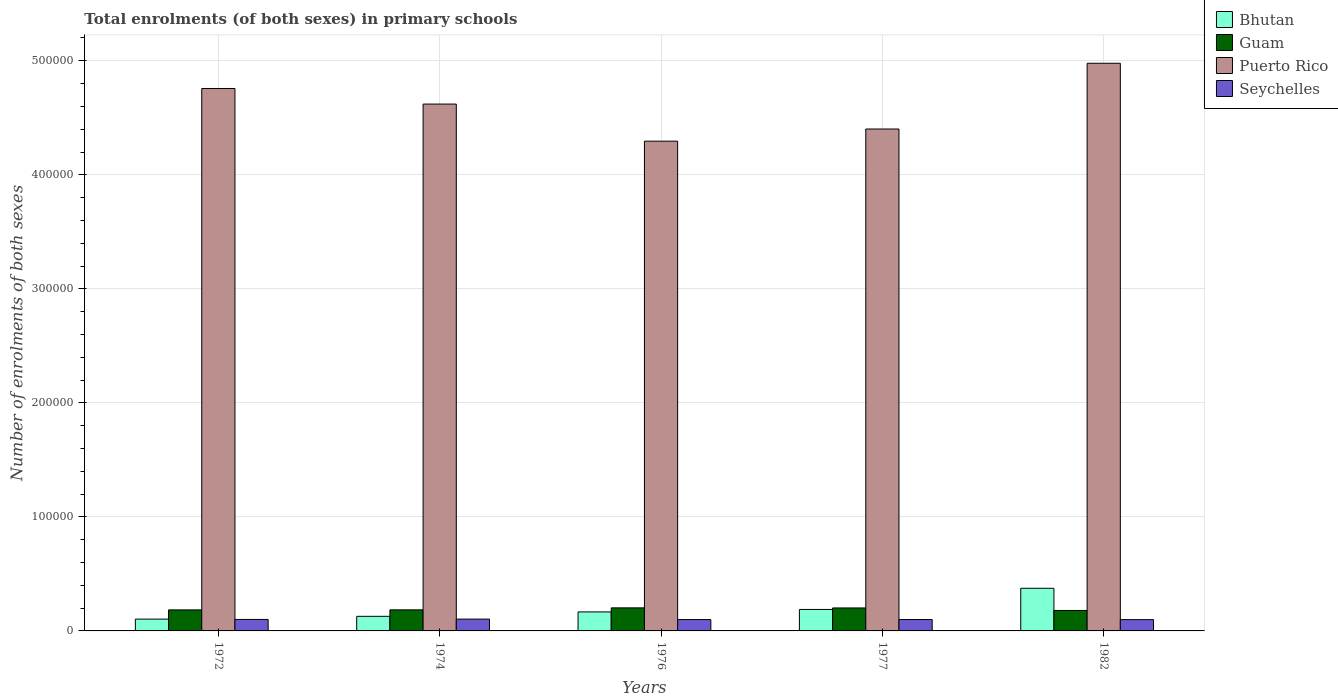How many groups of bars are there?
Keep it short and to the point. 5. Are the number of bars on each tick of the X-axis equal?
Your answer should be very brief. Yes. How many bars are there on the 1st tick from the right?
Your answer should be very brief. 4. What is the label of the 1st group of bars from the left?
Offer a very short reply. 1972. What is the number of enrolments in primary schools in Puerto Rico in 1974?
Your answer should be compact. 4.62e+05. Across all years, what is the maximum number of enrolments in primary schools in Puerto Rico?
Provide a succinct answer. 4.98e+05. Across all years, what is the minimum number of enrolments in primary schools in Seychelles?
Provide a succinct answer. 9897. In which year was the number of enrolments in primary schools in Bhutan maximum?
Provide a succinct answer. 1982. In which year was the number of enrolments in primary schools in Bhutan minimum?
Offer a terse response. 1972. What is the total number of enrolments in primary schools in Bhutan in the graph?
Provide a short and direct response. 9.61e+04. What is the difference between the number of enrolments in primary schools in Seychelles in 1974 and that in 1976?
Ensure brevity in your answer.  405. What is the difference between the number of enrolments in primary schools in Seychelles in 1982 and the number of enrolments in primary schools in Bhutan in 1976?
Your answer should be very brief. -6774. What is the average number of enrolments in primary schools in Puerto Rico per year?
Provide a succinct answer. 4.61e+05. In the year 1976, what is the difference between the number of enrolments in primary schools in Bhutan and number of enrolments in primary schools in Seychelles?
Provide a succinct answer. 6721. In how many years, is the number of enrolments in primary schools in Guam greater than 160000?
Ensure brevity in your answer.  0. What is the ratio of the number of enrolments in primary schools in Puerto Rico in 1974 to that in 1977?
Provide a short and direct response. 1.05. Is the number of enrolments in primary schools in Seychelles in 1977 less than that in 1982?
Your response must be concise. No. Is the difference between the number of enrolments in primary schools in Bhutan in 1974 and 1976 greater than the difference between the number of enrolments in primary schools in Seychelles in 1974 and 1976?
Give a very brief answer. No. What is the difference between the highest and the lowest number of enrolments in primary schools in Seychelles?
Provide a short and direct response. 458. In how many years, is the number of enrolments in primary schools in Seychelles greater than the average number of enrolments in primary schools in Seychelles taken over all years?
Offer a terse response. 2. Is it the case that in every year, the sum of the number of enrolments in primary schools in Seychelles and number of enrolments in primary schools in Puerto Rico is greater than the sum of number of enrolments in primary schools in Guam and number of enrolments in primary schools in Bhutan?
Provide a short and direct response. Yes. What does the 3rd bar from the left in 1977 represents?
Make the answer very short. Puerto Rico. What does the 4th bar from the right in 1976 represents?
Your answer should be compact. Bhutan. Is it the case that in every year, the sum of the number of enrolments in primary schools in Guam and number of enrolments in primary schools in Seychelles is greater than the number of enrolments in primary schools in Puerto Rico?
Provide a succinct answer. No. How many bars are there?
Your answer should be very brief. 20. What is the difference between two consecutive major ticks on the Y-axis?
Offer a very short reply. 1.00e+05. Are the values on the major ticks of Y-axis written in scientific E-notation?
Your answer should be very brief. No. Does the graph contain grids?
Your answer should be very brief. Yes. How many legend labels are there?
Your answer should be compact. 4. What is the title of the graph?
Ensure brevity in your answer.  Total enrolments (of both sexes) in primary schools. Does "Brazil" appear as one of the legend labels in the graph?
Offer a very short reply. No. What is the label or title of the Y-axis?
Keep it short and to the point. Number of enrolments of both sexes. What is the Number of enrolments of both sexes in Bhutan in 1972?
Offer a terse response. 1.04e+04. What is the Number of enrolments of both sexes in Guam in 1972?
Provide a succinct answer. 1.84e+04. What is the Number of enrolments of both sexes in Puerto Rico in 1972?
Make the answer very short. 4.76e+05. What is the Number of enrolments of both sexes of Seychelles in 1972?
Give a very brief answer. 1.01e+04. What is the Number of enrolments of both sexes in Bhutan in 1974?
Provide a short and direct response. 1.28e+04. What is the Number of enrolments of both sexes of Guam in 1974?
Offer a terse response. 1.85e+04. What is the Number of enrolments of both sexes of Puerto Rico in 1974?
Provide a succinct answer. 4.62e+05. What is the Number of enrolments of both sexes in Seychelles in 1974?
Keep it short and to the point. 1.04e+04. What is the Number of enrolments of both sexes of Bhutan in 1976?
Ensure brevity in your answer.  1.67e+04. What is the Number of enrolments of both sexes of Guam in 1976?
Give a very brief answer. 2.02e+04. What is the Number of enrolments of both sexes in Puerto Rico in 1976?
Give a very brief answer. 4.30e+05. What is the Number of enrolments of both sexes of Seychelles in 1976?
Ensure brevity in your answer.  9950. What is the Number of enrolments of both sexes of Bhutan in 1977?
Offer a very short reply. 1.88e+04. What is the Number of enrolments of both sexes in Guam in 1977?
Your answer should be very brief. 2.01e+04. What is the Number of enrolments of both sexes in Puerto Rico in 1977?
Offer a very short reply. 4.40e+05. What is the Number of enrolments of both sexes in Seychelles in 1977?
Make the answer very short. 1.00e+04. What is the Number of enrolments of both sexes of Bhutan in 1982?
Offer a terse response. 3.74e+04. What is the Number of enrolments of both sexes of Guam in 1982?
Provide a succinct answer. 1.79e+04. What is the Number of enrolments of both sexes of Puerto Rico in 1982?
Keep it short and to the point. 4.98e+05. What is the Number of enrolments of both sexes in Seychelles in 1982?
Ensure brevity in your answer.  9897. Across all years, what is the maximum Number of enrolments of both sexes of Bhutan?
Offer a very short reply. 3.74e+04. Across all years, what is the maximum Number of enrolments of both sexes in Guam?
Provide a short and direct response. 2.02e+04. Across all years, what is the maximum Number of enrolments of both sexes of Puerto Rico?
Ensure brevity in your answer.  4.98e+05. Across all years, what is the maximum Number of enrolments of both sexes in Seychelles?
Your answer should be very brief. 1.04e+04. Across all years, what is the minimum Number of enrolments of both sexes of Bhutan?
Ensure brevity in your answer.  1.04e+04. Across all years, what is the minimum Number of enrolments of both sexes of Guam?
Give a very brief answer. 1.79e+04. Across all years, what is the minimum Number of enrolments of both sexes in Puerto Rico?
Provide a short and direct response. 4.30e+05. Across all years, what is the minimum Number of enrolments of both sexes of Seychelles?
Offer a terse response. 9897. What is the total Number of enrolments of both sexes of Bhutan in the graph?
Give a very brief answer. 9.61e+04. What is the total Number of enrolments of both sexes of Guam in the graph?
Offer a very short reply. 9.52e+04. What is the total Number of enrolments of both sexes of Puerto Rico in the graph?
Offer a terse response. 2.31e+06. What is the total Number of enrolments of both sexes in Seychelles in the graph?
Your response must be concise. 5.03e+04. What is the difference between the Number of enrolments of both sexes in Bhutan in 1972 and that in 1974?
Offer a very short reply. -2449. What is the difference between the Number of enrolments of both sexes of Guam in 1972 and that in 1974?
Provide a succinct answer. -40. What is the difference between the Number of enrolments of both sexes in Puerto Rico in 1972 and that in 1974?
Make the answer very short. 1.37e+04. What is the difference between the Number of enrolments of both sexes of Seychelles in 1972 and that in 1974?
Provide a succinct answer. -281. What is the difference between the Number of enrolments of both sexes of Bhutan in 1972 and that in 1976?
Offer a very short reply. -6310. What is the difference between the Number of enrolments of both sexes in Guam in 1972 and that in 1976?
Make the answer very short. -1778. What is the difference between the Number of enrolments of both sexes in Puerto Rico in 1972 and that in 1976?
Your answer should be compact. 4.62e+04. What is the difference between the Number of enrolments of both sexes of Seychelles in 1972 and that in 1976?
Provide a short and direct response. 124. What is the difference between the Number of enrolments of both sexes of Bhutan in 1972 and that in 1977?
Make the answer very short. -8460. What is the difference between the Number of enrolments of both sexes of Guam in 1972 and that in 1977?
Provide a short and direct response. -1708. What is the difference between the Number of enrolments of both sexes in Puerto Rico in 1972 and that in 1977?
Your answer should be very brief. 3.55e+04. What is the difference between the Number of enrolments of both sexes in Bhutan in 1972 and that in 1982?
Provide a succinct answer. -2.70e+04. What is the difference between the Number of enrolments of both sexes in Guam in 1972 and that in 1982?
Make the answer very short. 492. What is the difference between the Number of enrolments of both sexes of Puerto Rico in 1972 and that in 1982?
Offer a very short reply. -2.21e+04. What is the difference between the Number of enrolments of both sexes of Seychelles in 1972 and that in 1982?
Your response must be concise. 177. What is the difference between the Number of enrolments of both sexes in Bhutan in 1974 and that in 1976?
Give a very brief answer. -3861. What is the difference between the Number of enrolments of both sexes in Guam in 1974 and that in 1976?
Your answer should be compact. -1738. What is the difference between the Number of enrolments of both sexes in Puerto Rico in 1974 and that in 1976?
Offer a terse response. 3.25e+04. What is the difference between the Number of enrolments of both sexes of Seychelles in 1974 and that in 1976?
Provide a succinct answer. 405. What is the difference between the Number of enrolments of both sexes in Bhutan in 1974 and that in 1977?
Provide a short and direct response. -6011. What is the difference between the Number of enrolments of both sexes of Guam in 1974 and that in 1977?
Keep it short and to the point. -1668. What is the difference between the Number of enrolments of both sexes of Puerto Rico in 1974 and that in 1977?
Offer a terse response. 2.19e+04. What is the difference between the Number of enrolments of both sexes of Seychelles in 1974 and that in 1977?
Make the answer very short. 354. What is the difference between the Number of enrolments of both sexes of Bhutan in 1974 and that in 1982?
Your response must be concise. -2.46e+04. What is the difference between the Number of enrolments of both sexes in Guam in 1974 and that in 1982?
Provide a short and direct response. 532. What is the difference between the Number of enrolments of both sexes of Puerto Rico in 1974 and that in 1982?
Provide a short and direct response. -3.58e+04. What is the difference between the Number of enrolments of both sexes of Seychelles in 1974 and that in 1982?
Your answer should be compact. 458. What is the difference between the Number of enrolments of both sexes of Bhutan in 1976 and that in 1977?
Provide a short and direct response. -2150. What is the difference between the Number of enrolments of both sexes in Guam in 1976 and that in 1977?
Your answer should be compact. 70. What is the difference between the Number of enrolments of both sexes of Puerto Rico in 1976 and that in 1977?
Make the answer very short. -1.07e+04. What is the difference between the Number of enrolments of both sexes in Seychelles in 1976 and that in 1977?
Provide a succinct answer. -51. What is the difference between the Number of enrolments of both sexes in Bhutan in 1976 and that in 1982?
Offer a very short reply. -2.07e+04. What is the difference between the Number of enrolments of both sexes of Guam in 1976 and that in 1982?
Your answer should be very brief. 2270. What is the difference between the Number of enrolments of both sexes of Puerto Rico in 1976 and that in 1982?
Keep it short and to the point. -6.83e+04. What is the difference between the Number of enrolments of both sexes of Seychelles in 1976 and that in 1982?
Ensure brevity in your answer.  53. What is the difference between the Number of enrolments of both sexes in Bhutan in 1977 and that in 1982?
Offer a terse response. -1.86e+04. What is the difference between the Number of enrolments of both sexes of Guam in 1977 and that in 1982?
Provide a succinct answer. 2200. What is the difference between the Number of enrolments of both sexes of Puerto Rico in 1977 and that in 1982?
Your response must be concise. -5.77e+04. What is the difference between the Number of enrolments of both sexes in Seychelles in 1977 and that in 1982?
Your answer should be compact. 104. What is the difference between the Number of enrolments of both sexes in Bhutan in 1972 and the Number of enrolments of both sexes in Guam in 1974?
Ensure brevity in your answer.  -8116. What is the difference between the Number of enrolments of both sexes in Bhutan in 1972 and the Number of enrolments of both sexes in Puerto Rico in 1974?
Keep it short and to the point. -4.52e+05. What is the difference between the Number of enrolments of both sexes in Bhutan in 1972 and the Number of enrolments of both sexes in Seychelles in 1974?
Provide a short and direct response. 6. What is the difference between the Number of enrolments of both sexes in Guam in 1972 and the Number of enrolments of both sexes in Puerto Rico in 1974?
Offer a terse response. -4.44e+05. What is the difference between the Number of enrolments of both sexes in Guam in 1972 and the Number of enrolments of both sexes in Seychelles in 1974?
Your answer should be very brief. 8082. What is the difference between the Number of enrolments of both sexes of Puerto Rico in 1972 and the Number of enrolments of both sexes of Seychelles in 1974?
Provide a short and direct response. 4.65e+05. What is the difference between the Number of enrolments of both sexes of Bhutan in 1972 and the Number of enrolments of both sexes of Guam in 1976?
Offer a very short reply. -9854. What is the difference between the Number of enrolments of both sexes in Bhutan in 1972 and the Number of enrolments of both sexes in Puerto Rico in 1976?
Make the answer very short. -4.19e+05. What is the difference between the Number of enrolments of both sexes of Bhutan in 1972 and the Number of enrolments of both sexes of Seychelles in 1976?
Provide a succinct answer. 411. What is the difference between the Number of enrolments of both sexes in Guam in 1972 and the Number of enrolments of both sexes in Puerto Rico in 1976?
Provide a succinct answer. -4.11e+05. What is the difference between the Number of enrolments of both sexes of Guam in 1972 and the Number of enrolments of both sexes of Seychelles in 1976?
Ensure brevity in your answer.  8487. What is the difference between the Number of enrolments of both sexes of Puerto Rico in 1972 and the Number of enrolments of both sexes of Seychelles in 1976?
Offer a very short reply. 4.66e+05. What is the difference between the Number of enrolments of both sexes in Bhutan in 1972 and the Number of enrolments of both sexes in Guam in 1977?
Your answer should be compact. -9784. What is the difference between the Number of enrolments of both sexes in Bhutan in 1972 and the Number of enrolments of both sexes in Puerto Rico in 1977?
Your answer should be compact. -4.30e+05. What is the difference between the Number of enrolments of both sexes of Bhutan in 1972 and the Number of enrolments of both sexes of Seychelles in 1977?
Provide a succinct answer. 360. What is the difference between the Number of enrolments of both sexes of Guam in 1972 and the Number of enrolments of both sexes of Puerto Rico in 1977?
Your answer should be compact. -4.22e+05. What is the difference between the Number of enrolments of both sexes in Guam in 1972 and the Number of enrolments of both sexes in Seychelles in 1977?
Offer a very short reply. 8436. What is the difference between the Number of enrolments of both sexes in Puerto Rico in 1972 and the Number of enrolments of both sexes in Seychelles in 1977?
Offer a terse response. 4.66e+05. What is the difference between the Number of enrolments of both sexes in Bhutan in 1972 and the Number of enrolments of both sexes in Guam in 1982?
Your response must be concise. -7584. What is the difference between the Number of enrolments of both sexes of Bhutan in 1972 and the Number of enrolments of both sexes of Puerto Rico in 1982?
Your answer should be very brief. -4.87e+05. What is the difference between the Number of enrolments of both sexes in Bhutan in 1972 and the Number of enrolments of both sexes in Seychelles in 1982?
Your answer should be very brief. 464. What is the difference between the Number of enrolments of both sexes in Guam in 1972 and the Number of enrolments of both sexes in Puerto Rico in 1982?
Ensure brevity in your answer.  -4.79e+05. What is the difference between the Number of enrolments of both sexes of Guam in 1972 and the Number of enrolments of both sexes of Seychelles in 1982?
Your answer should be very brief. 8540. What is the difference between the Number of enrolments of both sexes of Puerto Rico in 1972 and the Number of enrolments of both sexes of Seychelles in 1982?
Keep it short and to the point. 4.66e+05. What is the difference between the Number of enrolments of both sexes in Bhutan in 1974 and the Number of enrolments of both sexes in Guam in 1976?
Your response must be concise. -7405. What is the difference between the Number of enrolments of both sexes in Bhutan in 1974 and the Number of enrolments of both sexes in Puerto Rico in 1976?
Give a very brief answer. -4.17e+05. What is the difference between the Number of enrolments of both sexes of Bhutan in 1974 and the Number of enrolments of both sexes of Seychelles in 1976?
Ensure brevity in your answer.  2860. What is the difference between the Number of enrolments of both sexes of Guam in 1974 and the Number of enrolments of both sexes of Puerto Rico in 1976?
Offer a terse response. -4.11e+05. What is the difference between the Number of enrolments of both sexes of Guam in 1974 and the Number of enrolments of both sexes of Seychelles in 1976?
Offer a very short reply. 8527. What is the difference between the Number of enrolments of both sexes in Puerto Rico in 1974 and the Number of enrolments of both sexes in Seychelles in 1976?
Ensure brevity in your answer.  4.52e+05. What is the difference between the Number of enrolments of both sexes of Bhutan in 1974 and the Number of enrolments of both sexes of Guam in 1977?
Provide a short and direct response. -7335. What is the difference between the Number of enrolments of both sexes of Bhutan in 1974 and the Number of enrolments of both sexes of Puerto Rico in 1977?
Provide a succinct answer. -4.27e+05. What is the difference between the Number of enrolments of both sexes of Bhutan in 1974 and the Number of enrolments of both sexes of Seychelles in 1977?
Offer a very short reply. 2809. What is the difference between the Number of enrolments of both sexes in Guam in 1974 and the Number of enrolments of both sexes in Puerto Rico in 1977?
Your response must be concise. -4.22e+05. What is the difference between the Number of enrolments of both sexes of Guam in 1974 and the Number of enrolments of both sexes of Seychelles in 1977?
Your response must be concise. 8476. What is the difference between the Number of enrolments of both sexes of Puerto Rico in 1974 and the Number of enrolments of both sexes of Seychelles in 1977?
Your answer should be very brief. 4.52e+05. What is the difference between the Number of enrolments of both sexes of Bhutan in 1974 and the Number of enrolments of both sexes of Guam in 1982?
Give a very brief answer. -5135. What is the difference between the Number of enrolments of both sexes in Bhutan in 1974 and the Number of enrolments of both sexes in Puerto Rico in 1982?
Your answer should be compact. -4.85e+05. What is the difference between the Number of enrolments of both sexes in Bhutan in 1974 and the Number of enrolments of both sexes in Seychelles in 1982?
Give a very brief answer. 2913. What is the difference between the Number of enrolments of both sexes in Guam in 1974 and the Number of enrolments of both sexes in Puerto Rico in 1982?
Your answer should be very brief. -4.79e+05. What is the difference between the Number of enrolments of both sexes in Guam in 1974 and the Number of enrolments of both sexes in Seychelles in 1982?
Ensure brevity in your answer.  8580. What is the difference between the Number of enrolments of both sexes of Puerto Rico in 1974 and the Number of enrolments of both sexes of Seychelles in 1982?
Your answer should be compact. 4.52e+05. What is the difference between the Number of enrolments of both sexes of Bhutan in 1976 and the Number of enrolments of both sexes of Guam in 1977?
Provide a succinct answer. -3474. What is the difference between the Number of enrolments of both sexes of Bhutan in 1976 and the Number of enrolments of both sexes of Puerto Rico in 1977?
Your answer should be very brief. -4.23e+05. What is the difference between the Number of enrolments of both sexes in Bhutan in 1976 and the Number of enrolments of both sexes in Seychelles in 1977?
Your response must be concise. 6670. What is the difference between the Number of enrolments of both sexes in Guam in 1976 and the Number of enrolments of both sexes in Puerto Rico in 1977?
Offer a very short reply. -4.20e+05. What is the difference between the Number of enrolments of both sexes of Guam in 1976 and the Number of enrolments of both sexes of Seychelles in 1977?
Offer a terse response. 1.02e+04. What is the difference between the Number of enrolments of both sexes in Puerto Rico in 1976 and the Number of enrolments of both sexes in Seychelles in 1977?
Provide a short and direct response. 4.20e+05. What is the difference between the Number of enrolments of both sexes of Bhutan in 1976 and the Number of enrolments of both sexes of Guam in 1982?
Ensure brevity in your answer.  -1274. What is the difference between the Number of enrolments of both sexes of Bhutan in 1976 and the Number of enrolments of both sexes of Puerto Rico in 1982?
Offer a terse response. -4.81e+05. What is the difference between the Number of enrolments of both sexes in Bhutan in 1976 and the Number of enrolments of both sexes in Seychelles in 1982?
Offer a very short reply. 6774. What is the difference between the Number of enrolments of both sexes in Guam in 1976 and the Number of enrolments of both sexes in Puerto Rico in 1982?
Keep it short and to the point. -4.78e+05. What is the difference between the Number of enrolments of both sexes in Guam in 1976 and the Number of enrolments of both sexes in Seychelles in 1982?
Offer a very short reply. 1.03e+04. What is the difference between the Number of enrolments of both sexes in Puerto Rico in 1976 and the Number of enrolments of both sexes in Seychelles in 1982?
Provide a succinct answer. 4.20e+05. What is the difference between the Number of enrolments of both sexes of Bhutan in 1977 and the Number of enrolments of both sexes of Guam in 1982?
Offer a very short reply. 876. What is the difference between the Number of enrolments of both sexes of Bhutan in 1977 and the Number of enrolments of both sexes of Puerto Rico in 1982?
Make the answer very short. -4.79e+05. What is the difference between the Number of enrolments of both sexes of Bhutan in 1977 and the Number of enrolments of both sexes of Seychelles in 1982?
Provide a short and direct response. 8924. What is the difference between the Number of enrolments of both sexes of Guam in 1977 and the Number of enrolments of both sexes of Puerto Rico in 1982?
Your answer should be compact. -4.78e+05. What is the difference between the Number of enrolments of both sexes in Guam in 1977 and the Number of enrolments of both sexes in Seychelles in 1982?
Your answer should be very brief. 1.02e+04. What is the difference between the Number of enrolments of both sexes of Puerto Rico in 1977 and the Number of enrolments of both sexes of Seychelles in 1982?
Offer a very short reply. 4.30e+05. What is the average Number of enrolments of both sexes of Bhutan per year?
Make the answer very short. 1.92e+04. What is the average Number of enrolments of both sexes in Guam per year?
Your answer should be compact. 1.90e+04. What is the average Number of enrolments of both sexes of Puerto Rico per year?
Ensure brevity in your answer.  4.61e+05. What is the average Number of enrolments of both sexes of Seychelles per year?
Your answer should be compact. 1.01e+04. In the year 1972, what is the difference between the Number of enrolments of both sexes of Bhutan and Number of enrolments of both sexes of Guam?
Provide a short and direct response. -8076. In the year 1972, what is the difference between the Number of enrolments of both sexes in Bhutan and Number of enrolments of both sexes in Puerto Rico?
Provide a short and direct response. -4.65e+05. In the year 1972, what is the difference between the Number of enrolments of both sexes of Bhutan and Number of enrolments of both sexes of Seychelles?
Keep it short and to the point. 287. In the year 1972, what is the difference between the Number of enrolments of both sexes of Guam and Number of enrolments of both sexes of Puerto Rico?
Ensure brevity in your answer.  -4.57e+05. In the year 1972, what is the difference between the Number of enrolments of both sexes in Guam and Number of enrolments of both sexes in Seychelles?
Give a very brief answer. 8363. In the year 1972, what is the difference between the Number of enrolments of both sexes in Puerto Rico and Number of enrolments of both sexes in Seychelles?
Keep it short and to the point. 4.66e+05. In the year 1974, what is the difference between the Number of enrolments of both sexes in Bhutan and Number of enrolments of both sexes in Guam?
Ensure brevity in your answer.  -5667. In the year 1974, what is the difference between the Number of enrolments of both sexes in Bhutan and Number of enrolments of both sexes in Puerto Rico?
Give a very brief answer. -4.49e+05. In the year 1974, what is the difference between the Number of enrolments of both sexes of Bhutan and Number of enrolments of both sexes of Seychelles?
Offer a terse response. 2455. In the year 1974, what is the difference between the Number of enrolments of both sexes of Guam and Number of enrolments of both sexes of Puerto Rico?
Make the answer very short. -4.44e+05. In the year 1974, what is the difference between the Number of enrolments of both sexes in Guam and Number of enrolments of both sexes in Seychelles?
Ensure brevity in your answer.  8122. In the year 1974, what is the difference between the Number of enrolments of both sexes in Puerto Rico and Number of enrolments of both sexes in Seychelles?
Your answer should be very brief. 4.52e+05. In the year 1976, what is the difference between the Number of enrolments of both sexes in Bhutan and Number of enrolments of both sexes in Guam?
Keep it short and to the point. -3544. In the year 1976, what is the difference between the Number of enrolments of both sexes of Bhutan and Number of enrolments of both sexes of Puerto Rico?
Give a very brief answer. -4.13e+05. In the year 1976, what is the difference between the Number of enrolments of both sexes of Bhutan and Number of enrolments of both sexes of Seychelles?
Offer a very short reply. 6721. In the year 1976, what is the difference between the Number of enrolments of both sexes in Guam and Number of enrolments of both sexes in Puerto Rico?
Provide a short and direct response. -4.09e+05. In the year 1976, what is the difference between the Number of enrolments of both sexes of Guam and Number of enrolments of both sexes of Seychelles?
Your answer should be compact. 1.03e+04. In the year 1976, what is the difference between the Number of enrolments of both sexes in Puerto Rico and Number of enrolments of both sexes in Seychelles?
Your answer should be very brief. 4.20e+05. In the year 1977, what is the difference between the Number of enrolments of both sexes of Bhutan and Number of enrolments of both sexes of Guam?
Your answer should be compact. -1324. In the year 1977, what is the difference between the Number of enrolments of both sexes of Bhutan and Number of enrolments of both sexes of Puerto Rico?
Your response must be concise. -4.21e+05. In the year 1977, what is the difference between the Number of enrolments of both sexes of Bhutan and Number of enrolments of both sexes of Seychelles?
Provide a short and direct response. 8820. In the year 1977, what is the difference between the Number of enrolments of both sexes in Guam and Number of enrolments of both sexes in Puerto Rico?
Your response must be concise. -4.20e+05. In the year 1977, what is the difference between the Number of enrolments of both sexes in Guam and Number of enrolments of both sexes in Seychelles?
Your response must be concise. 1.01e+04. In the year 1977, what is the difference between the Number of enrolments of both sexes in Puerto Rico and Number of enrolments of both sexes in Seychelles?
Your response must be concise. 4.30e+05. In the year 1982, what is the difference between the Number of enrolments of both sexes in Bhutan and Number of enrolments of both sexes in Guam?
Make the answer very short. 1.95e+04. In the year 1982, what is the difference between the Number of enrolments of both sexes in Bhutan and Number of enrolments of both sexes in Puerto Rico?
Your answer should be compact. -4.60e+05. In the year 1982, what is the difference between the Number of enrolments of both sexes of Bhutan and Number of enrolments of both sexes of Seychelles?
Provide a short and direct response. 2.75e+04. In the year 1982, what is the difference between the Number of enrolments of both sexes in Guam and Number of enrolments of both sexes in Puerto Rico?
Provide a short and direct response. -4.80e+05. In the year 1982, what is the difference between the Number of enrolments of both sexes of Guam and Number of enrolments of both sexes of Seychelles?
Your response must be concise. 8048. In the year 1982, what is the difference between the Number of enrolments of both sexes of Puerto Rico and Number of enrolments of both sexes of Seychelles?
Make the answer very short. 4.88e+05. What is the ratio of the Number of enrolments of both sexes of Bhutan in 1972 to that in 1974?
Keep it short and to the point. 0.81. What is the ratio of the Number of enrolments of both sexes of Puerto Rico in 1972 to that in 1974?
Your answer should be compact. 1.03. What is the ratio of the Number of enrolments of both sexes of Seychelles in 1972 to that in 1974?
Offer a very short reply. 0.97. What is the ratio of the Number of enrolments of both sexes of Bhutan in 1972 to that in 1976?
Keep it short and to the point. 0.62. What is the ratio of the Number of enrolments of both sexes in Guam in 1972 to that in 1976?
Provide a succinct answer. 0.91. What is the ratio of the Number of enrolments of both sexes of Puerto Rico in 1972 to that in 1976?
Ensure brevity in your answer.  1.11. What is the ratio of the Number of enrolments of both sexes of Seychelles in 1972 to that in 1976?
Your answer should be very brief. 1.01. What is the ratio of the Number of enrolments of both sexes in Bhutan in 1972 to that in 1977?
Your answer should be very brief. 0.55. What is the ratio of the Number of enrolments of both sexes in Guam in 1972 to that in 1977?
Your answer should be compact. 0.92. What is the ratio of the Number of enrolments of both sexes in Puerto Rico in 1972 to that in 1977?
Your response must be concise. 1.08. What is the ratio of the Number of enrolments of both sexes in Seychelles in 1972 to that in 1977?
Your answer should be compact. 1.01. What is the ratio of the Number of enrolments of both sexes of Bhutan in 1972 to that in 1982?
Offer a terse response. 0.28. What is the ratio of the Number of enrolments of both sexes of Guam in 1972 to that in 1982?
Your answer should be very brief. 1.03. What is the ratio of the Number of enrolments of both sexes of Puerto Rico in 1972 to that in 1982?
Provide a succinct answer. 0.96. What is the ratio of the Number of enrolments of both sexes of Seychelles in 1972 to that in 1982?
Your answer should be very brief. 1.02. What is the ratio of the Number of enrolments of both sexes of Bhutan in 1974 to that in 1976?
Keep it short and to the point. 0.77. What is the ratio of the Number of enrolments of both sexes in Guam in 1974 to that in 1976?
Ensure brevity in your answer.  0.91. What is the ratio of the Number of enrolments of both sexes in Puerto Rico in 1974 to that in 1976?
Make the answer very short. 1.08. What is the ratio of the Number of enrolments of both sexes of Seychelles in 1974 to that in 1976?
Make the answer very short. 1.04. What is the ratio of the Number of enrolments of both sexes in Bhutan in 1974 to that in 1977?
Offer a very short reply. 0.68. What is the ratio of the Number of enrolments of both sexes of Guam in 1974 to that in 1977?
Provide a succinct answer. 0.92. What is the ratio of the Number of enrolments of both sexes of Puerto Rico in 1974 to that in 1977?
Your answer should be compact. 1.05. What is the ratio of the Number of enrolments of both sexes of Seychelles in 1974 to that in 1977?
Make the answer very short. 1.04. What is the ratio of the Number of enrolments of both sexes in Bhutan in 1974 to that in 1982?
Keep it short and to the point. 0.34. What is the ratio of the Number of enrolments of both sexes in Guam in 1974 to that in 1982?
Offer a very short reply. 1.03. What is the ratio of the Number of enrolments of both sexes in Puerto Rico in 1974 to that in 1982?
Your answer should be compact. 0.93. What is the ratio of the Number of enrolments of both sexes in Seychelles in 1974 to that in 1982?
Ensure brevity in your answer.  1.05. What is the ratio of the Number of enrolments of both sexes of Bhutan in 1976 to that in 1977?
Give a very brief answer. 0.89. What is the ratio of the Number of enrolments of both sexes of Guam in 1976 to that in 1977?
Your answer should be compact. 1. What is the ratio of the Number of enrolments of both sexes in Puerto Rico in 1976 to that in 1977?
Offer a terse response. 0.98. What is the ratio of the Number of enrolments of both sexes in Bhutan in 1976 to that in 1982?
Offer a very short reply. 0.45. What is the ratio of the Number of enrolments of both sexes of Guam in 1976 to that in 1982?
Make the answer very short. 1.13. What is the ratio of the Number of enrolments of both sexes in Puerto Rico in 1976 to that in 1982?
Ensure brevity in your answer.  0.86. What is the ratio of the Number of enrolments of both sexes of Seychelles in 1976 to that in 1982?
Offer a terse response. 1.01. What is the ratio of the Number of enrolments of both sexes in Bhutan in 1977 to that in 1982?
Your response must be concise. 0.5. What is the ratio of the Number of enrolments of both sexes of Guam in 1977 to that in 1982?
Provide a short and direct response. 1.12. What is the ratio of the Number of enrolments of both sexes in Puerto Rico in 1977 to that in 1982?
Keep it short and to the point. 0.88. What is the ratio of the Number of enrolments of both sexes of Seychelles in 1977 to that in 1982?
Your answer should be very brief. 1.01. What is the difference between the highest and the second highest Number of enrolments of both sexes of Bhutan?
Ensure brevity in your answer.  1.86e+04. What is the difference between the highest and the second highest Number of enrolments of both sexes in Puerto Rico?
Give a very brief answer. 2.21e+04. What is the difference between the highest and the second highest Number of enrolments of both sexes of Seychelles?
Provide a short and direct response. 281. What is the difference between the highest and the lowest Number of enrolments of both sexes of Bhutan?
Keep it short and to the point. 2.70e+04. What is the difference between the highest and the lowest Number of enrolments of both sexes in Guam?
Your answer should be compact. 2270. What is the difference between the highest and the lowest Number of enrolments of both sexes of Puerto Rico?
Your answer should be compact. 6.83e+04. What is the difference between the highest and the lowest Number of enrolments of both sexes of Seychelles?
Offer a terse response. 458. 